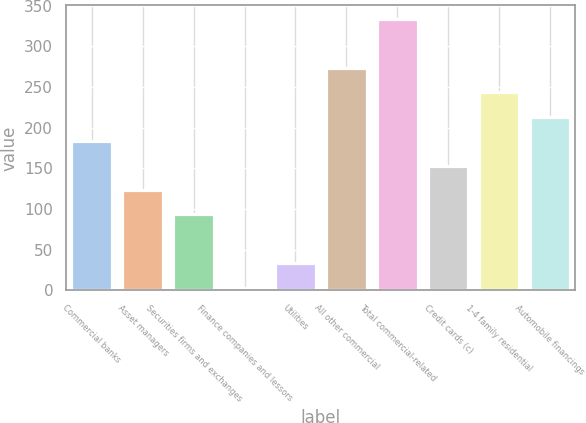<chart> <loc_0><loc_0><loc_500><loc_500><bar_chart><fcel>Commercial banks<fcel>Asset managers<fcel>Securities firms and exchanges<fcel>Finance companies and lessors<fcel>Utilities<fcel>All other commercial<fcel>Total commercial-related<fcel>Credit cards (c)<fcel>1-4 family residential<fcel>Automobile financings<nl><fcel>183.28<fcel>123.22<fcel>93.19<fcel>3.1<fcel>33.13<fcel>273.37<fcel>333.43<fcel>153.25<fcel>243.34<fcel>213.31<nl></chart> 